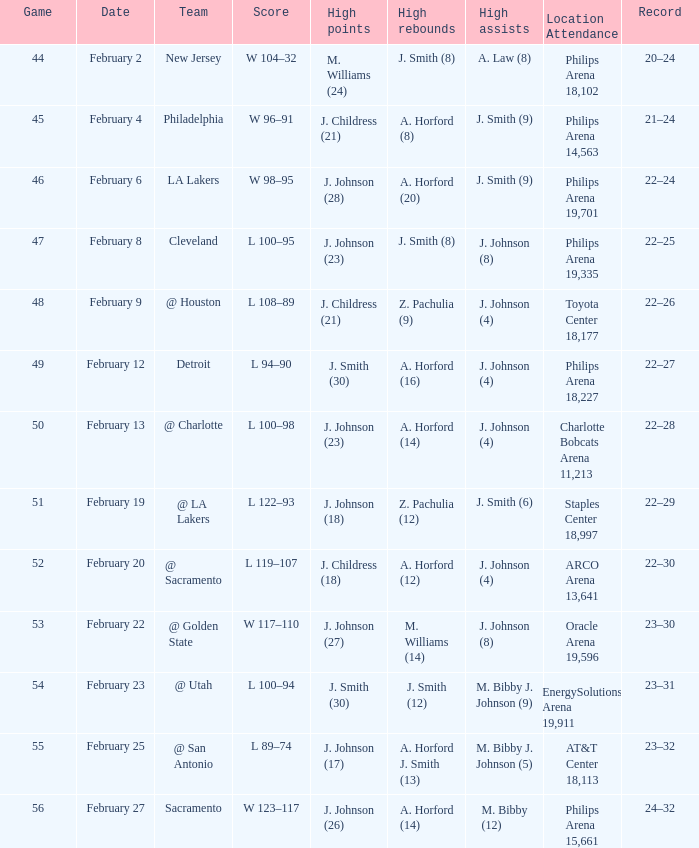Name the number of teams at the philips arena 19,335? 1.0. 